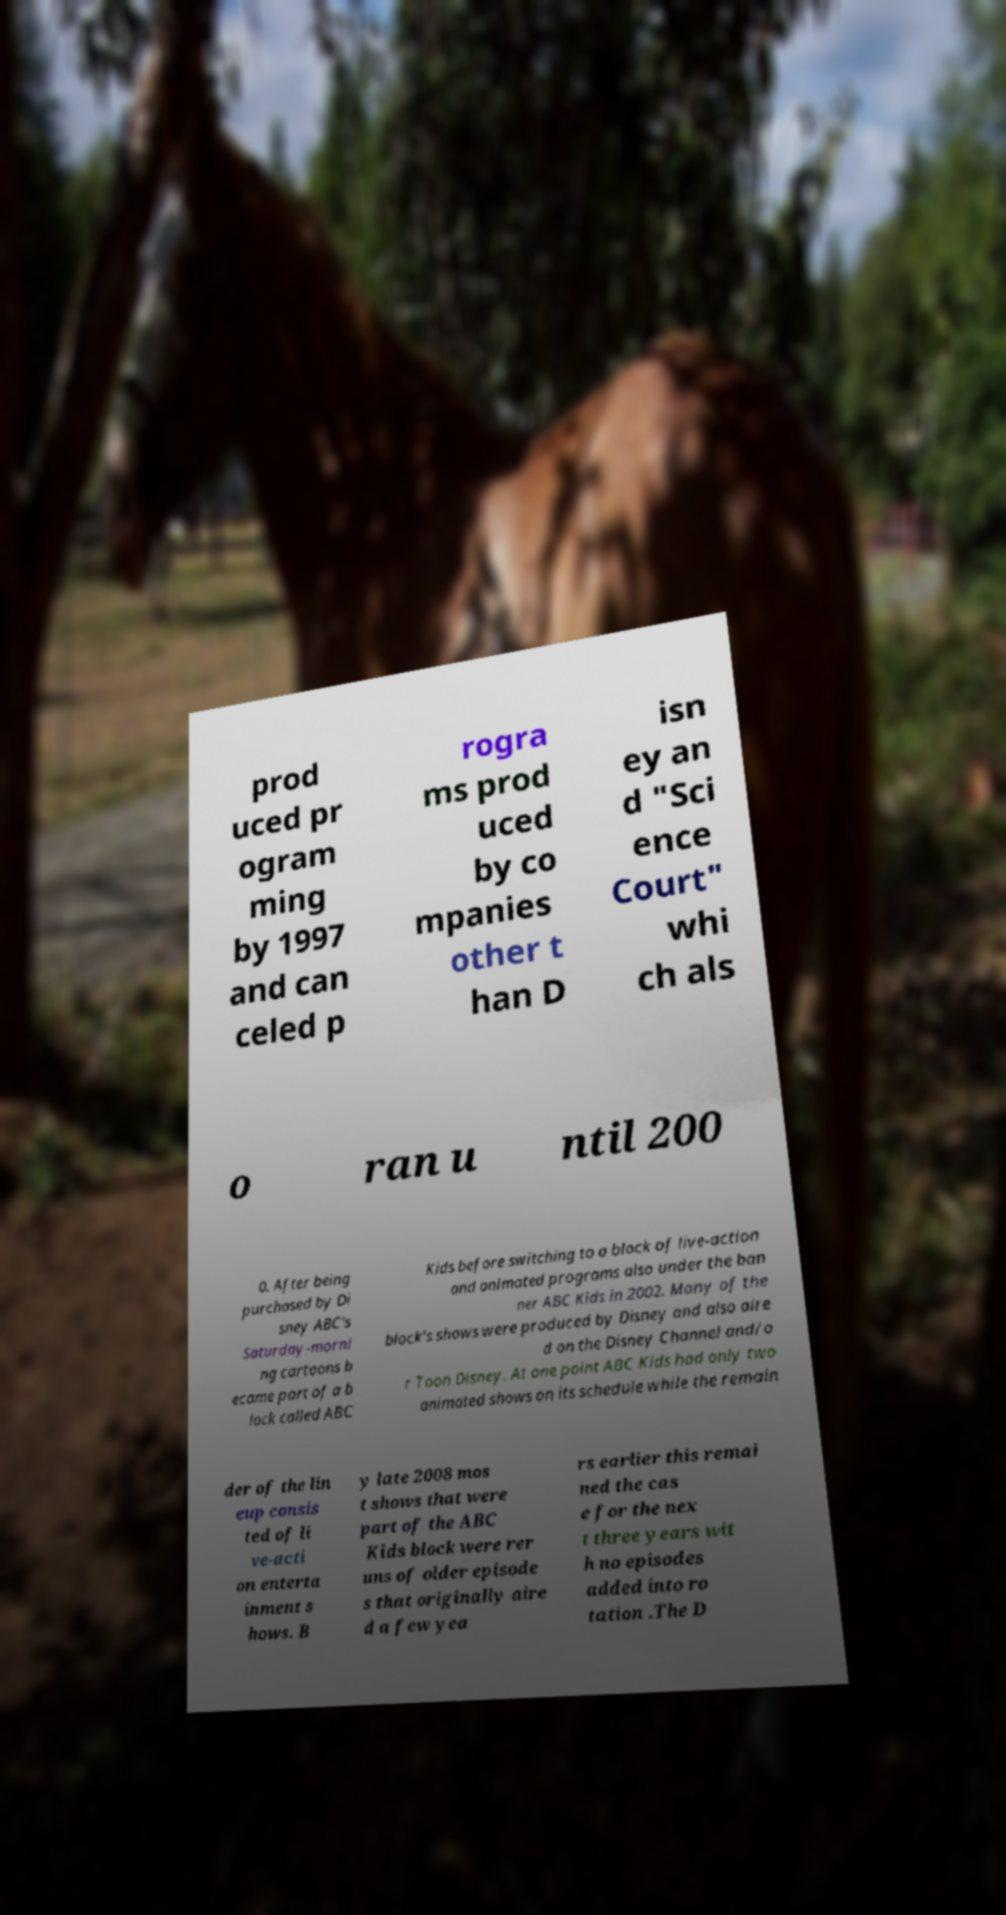What messages or text are displayed in this image? I need them in a readable, typed format. prod uced pr ogram ming by 1997 and can celed p rogra ms prod uced by co mpanies other t han D isn ey an d "Sci ence Court" whi ch als o ran u ntil 200 0. After being purchased by Di sney ABC's Saturday-morni ng cartoons b ecame part of a b lock called ABC Kids before switching to a block of live-action and animated programs also under the ban ner ABC Kids in 2002. Many of the block's shows were produced by Disney and also aire d on the Disney Channel and/o r Toon Disney. At one point ABC Kids had only two animated shows on its schedule while the remain der of the lin eup consis ted of li ve-acti on enterta inment s hows. B y late 2008 mos t shows that were part of the ABC Kids block were rer uns of older episode s that originally aire d a few yea rs earlier this remai ned the cas e for the nex t three years wit h no episodes added into ro tation .The D 